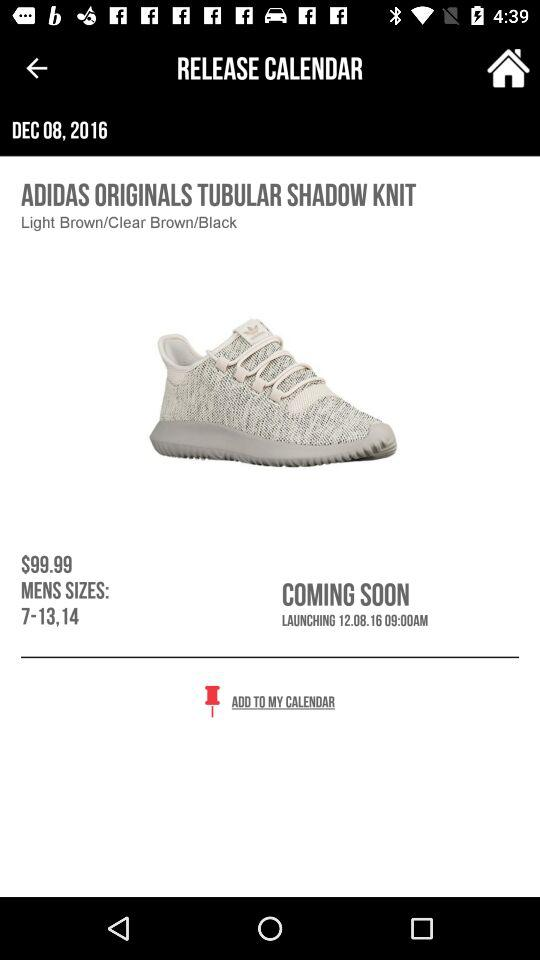Which color is available for "ADIDAS ORIGINALS TUBULAR SHADOW KNIT" shoes? The colors available are light brown, clear brown and black. 